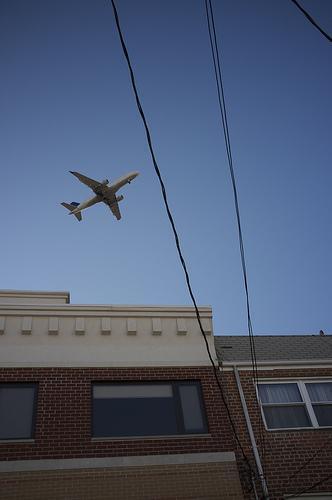How many planes?
Give a very brief answer. 1. 